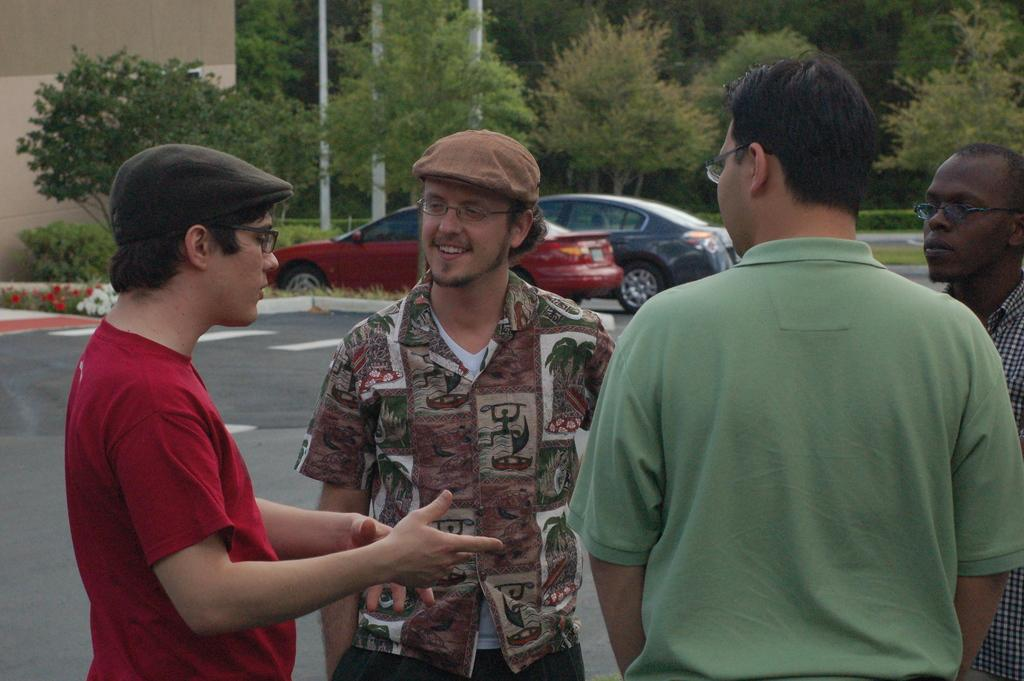What can be seen in the foreground of the image? There are people standing in the front of the image. What is visible in the background of the image? There is a house, poles, trees, grass, and cars in the background of the image. Can you describe the setting of the image? The image appears to be set in an outdoor area with a house and various natural elements in the background. What type of pie is being served to the people in the image? There is no pie present in the image; it features people standing in front of a background with a house, poles, trees, grass, and cars. 